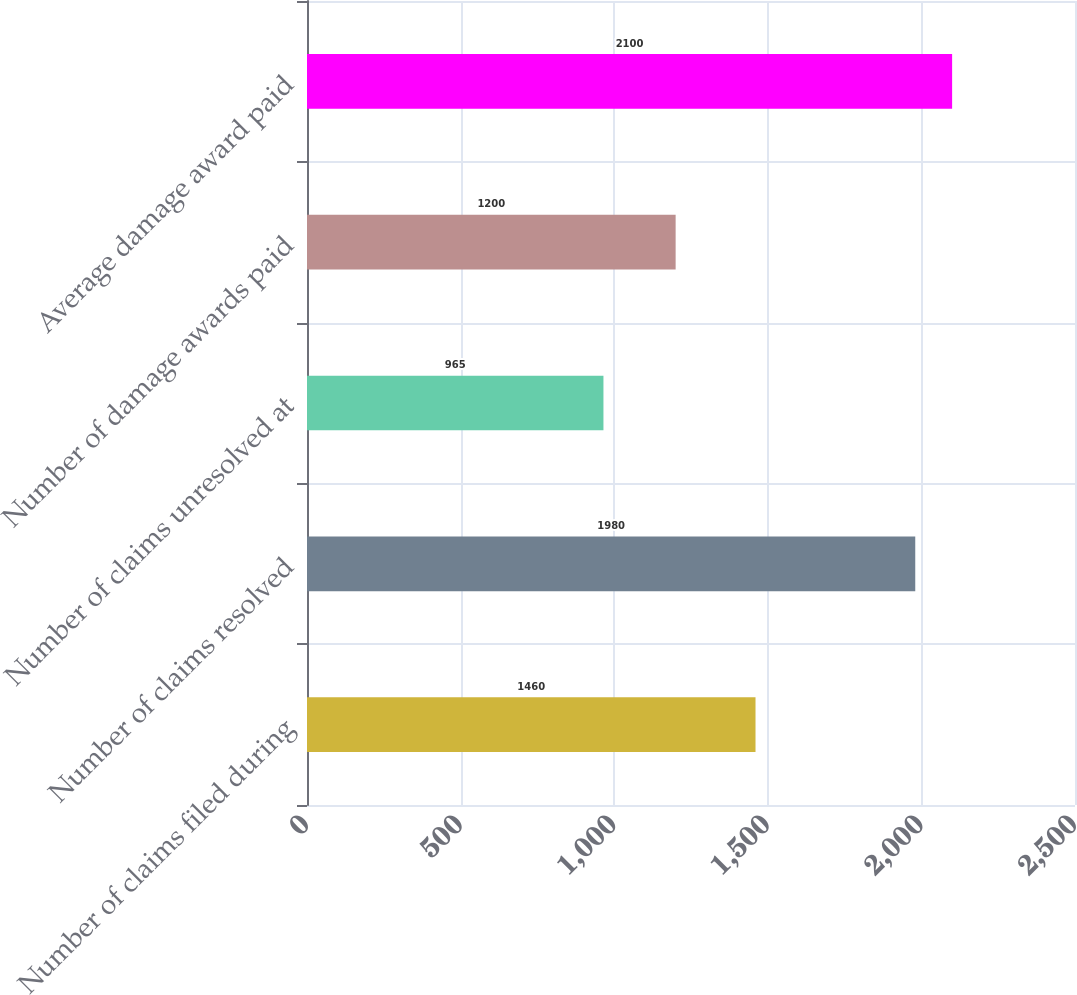Convert chart. <chart><loc_0><loc_0><loc_500><loc_500><bar_chart><fcel>Number of claims filed during<fcel>Number of claims resolved<fcel>Number of claims unresolved at<fcel>Number of damage awards paid<fcel>Average damage award paid<nl><fcel>1460<fcel>1980<fcel>965<fcel>1200<fcel>2100<nl></chart> 